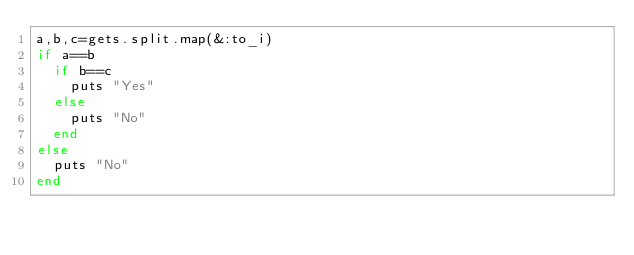Convert code to text. <code><loc_0><loc_0><loc_500><loc_500><_Ruby_>a,b,c=gets.split.map(&:to_i)
if a==b
  if b==c
    puts "Yes"
  else
    puts "No"
  end
else
  puts "No"
end</code> 